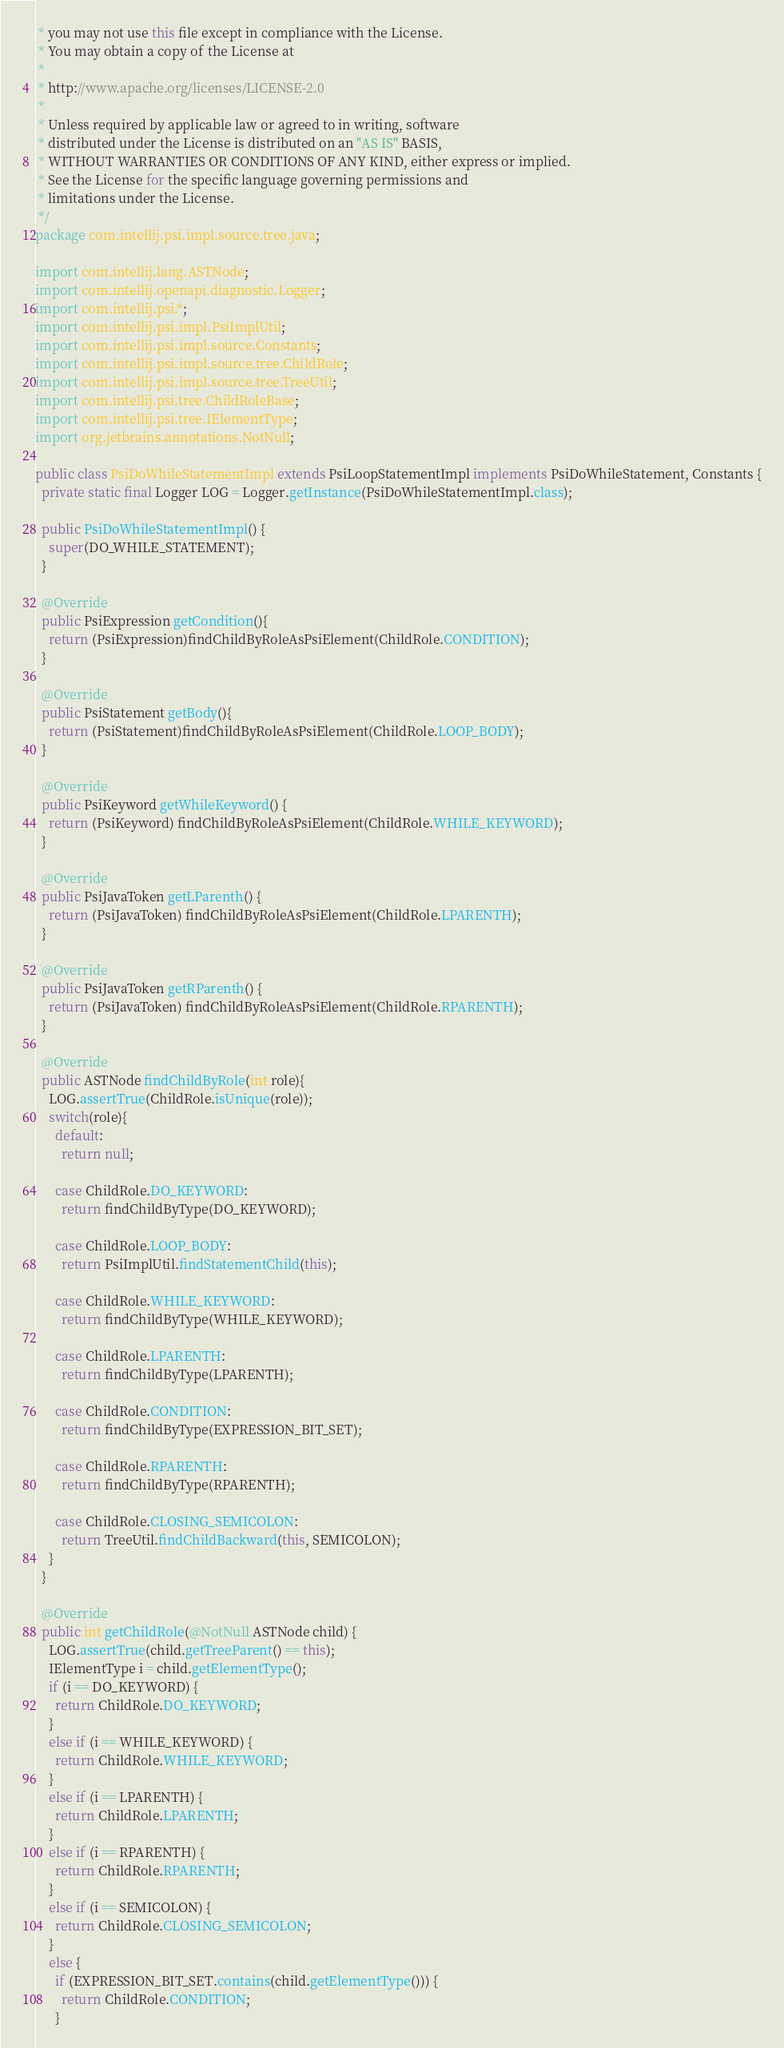<code> <loc_0><loc_0><loc_500><loc_500><_Java_> * you may not use this file except in compliance with the License.
 * You may obtain a copy of the License at
 *
 * http://www.apache.org/licenses/LICENSE-2.0
 *
 * Unless required by applicable law or agreed to in writing, software
 * distributed under the License is distributed on an "AS IS" BASIS,
 * WITHOUT WARRANTIES OR CONDITIONS OF ANY KIND, either express or implied.
 * See the License for the specific language governing permissions and
 * limitations under the License.
 */
package com.intellij.psi.impl.source.tree.java;

import com.intellij.lang.ASTNode;
import com.intellij.openapi.diagnostic.Logger;
import com.intellij.psi.*;
import com.intellij.psi.impl.PsiImplUtil;
import com.intellij.psi.impl.source.Constants;
import com.intellij.psi.impl.source.tree.ChildRole;
import com.intellij.psi.impl.source.tree.TreeUtil;
import com.intellij.psi.tree.ChildRoleBase;
import com.intellij.psi.tree.IElementType;
import org.jetbrains.annotations.NotNull;

public class PsiDoWhileStatementImpl extends PsiLoopStatementImpl implements PsiDoWhileStatement, Constants {
  private static final Logger LOG = Logger.getInstance(PsiDoWhileStatementImpl.class);

  public PsiDoWhileStatementImpl() {
    super(DO_WHILE_STATEMENT);
  }

  @Override
  public PsiExpression getCondition(){
    return (PsiExpression)findChildByRoleAsPsiElement(ChildRole.CONDITION);
  }

  @Override
  public PsiStatement getBody(){
    return (PsiStatement)findChildByRoleAsPsiElement(ChildRole.LOOP_BODY);
  }

  @Override
  public PsiKeyword getWhileKeyword() {
    return (PsiKeyword) findChildByRoleAsPsiElement(ChildRole.WHILE_KEYWORD);
  }

  @Override
  public PsiJavaToken getLParenth() {
    return (PsiJavaToken) findChildByRoleAsPsiElement(ChildRole.LPARENTH);
  }

  @Override
  public PsiJavaToken getRParenth() {
    return (PsiJavaToken) findChildByRoleAsPsiElement(ChildRole.RPARENTH);
  }

  @Override
  public ASTNode findChildByRole(int role){
    LOG.assertTrue(ChildRole.isUnique(role));
    switch(role){
      default:
        return null;

      case ChildRole.DO_KEYWORD:
        return findChildByType(DO_KEYWORD);

      case ChildRole.LOOP_BODY:
        return PsiImplUtil.findStatementChild(this);

      case ChildRole.WHILE_KEYWORD:
        return findChildByType(WHILE_KEYWORD);

      case ChildRole.LPARENTH:
        return findChildByType(LPARENTH);

      case ChildRole.CONDITION:
        return findChildByType(EXPRESSION_BIT_SET);

      case ChildRole.RPARENTH:
        return findChildByType(RPARENTH);

      case ChildRole.CLOSING_SEMICOLON:
        return TreeUtil.findChildBackward(this, SEMICOLON);
    }
  }

  @Override
  public int getChildRole(@NotNull ASTNode child) {
    LOG.assertTrue(child.getTreeParent() == this);
    IElementType i = child.getElementType();
    if (i == DO_KEYWORD) {
      return ChildRole.DO_KEYWORD;
    }
    else if (i == WHILE_KEYWORD) {
      return ChildRole.WHILE_KEYWORD;
    }
    else if (i == LPARENTH) {
      return ChildRole.LPARENTH;
    }
    else if (i == RPARENTH) {
      return ChildRole.RPARENTH;
    }
    else if (i == SEMICOLON) {
      return ChildRole.CLOSING_SEMICOLON;
    }
    else {
      if (EXPRESSION_BIT_SET.contains(child.getElementType())) {
        return ChildRole.CONDITION;
      }</code> 